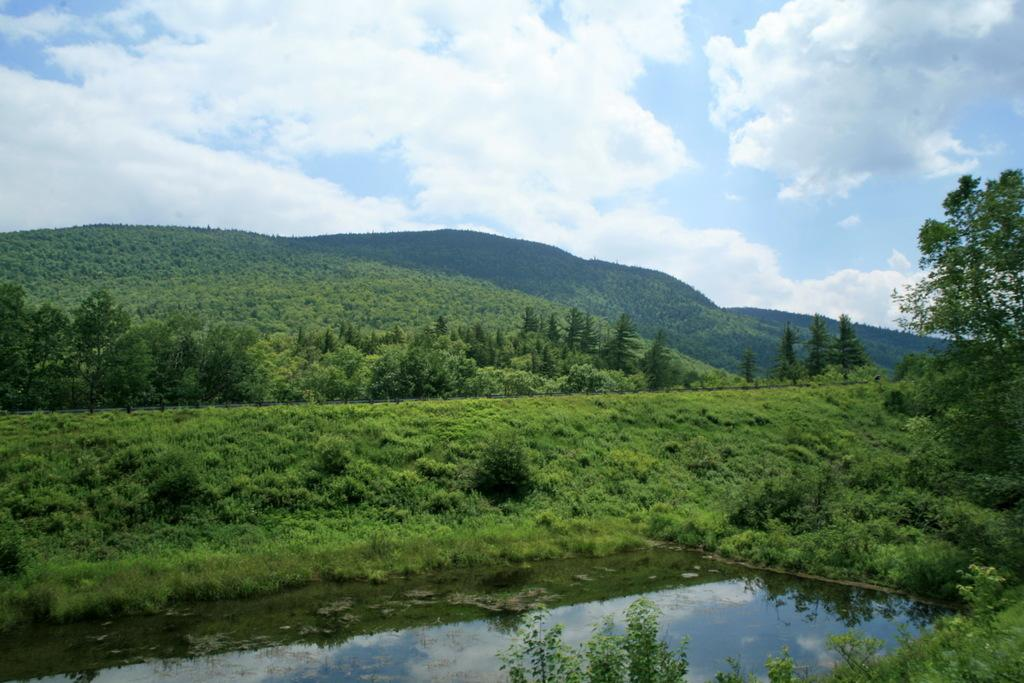What geographical features are located in the center of the image? There are hills in the center of the image. What type of vegetation can be seen in the image? Trees are present in the image. What body of water is visible at the bottom of the image? There is water at the bottom of the image. What can be seen in the sky at the top of the image? Clouds are visible in the sky at the top of the image. What type of protest is taking place in the image? There is no protest present in the image; it features hills, trees, water, and clouds. What shape is the copy machine in the image? There is no copy machine present in the image. 